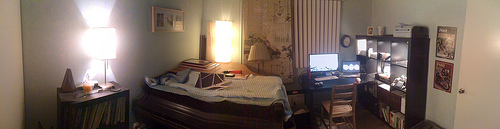Please provide a short description for this region: [0.63, 0.53, 0.73, 0.62]. Within the provided coordinates, one can see a sturdy, ergonomic office chair with black cushioning, tucked neatly under a wooden computer desk cluttered with various items. 